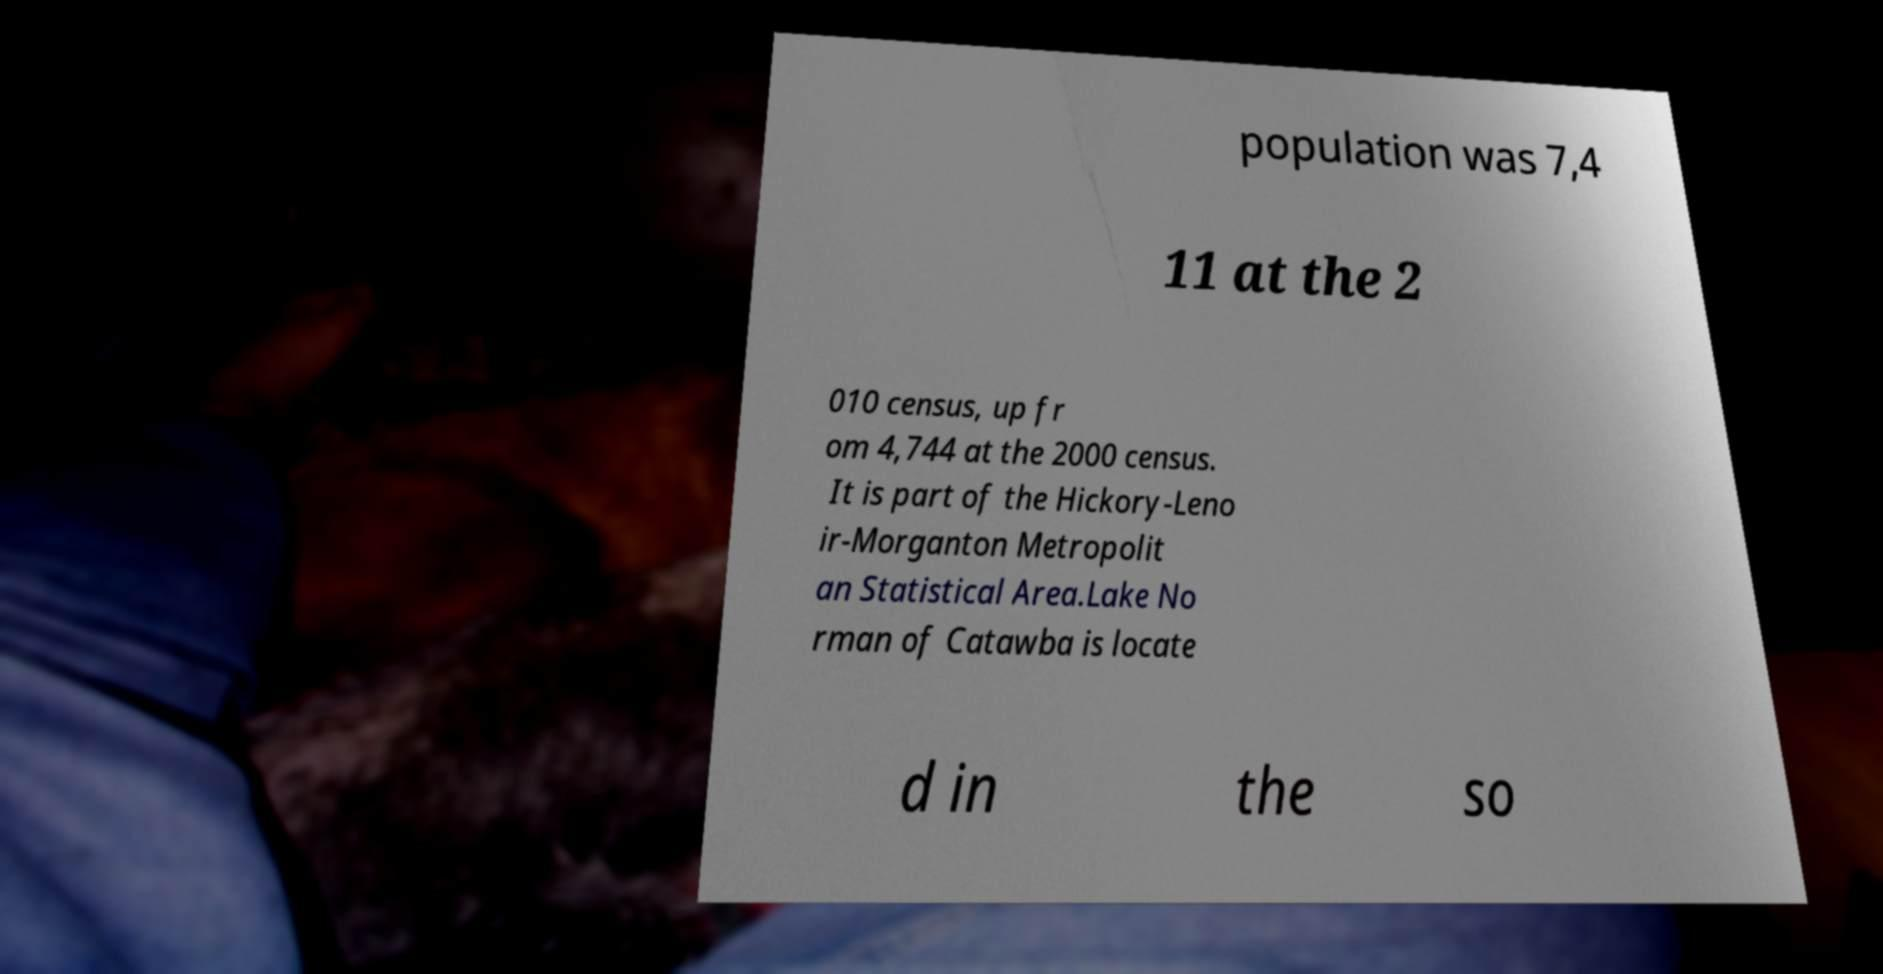What messages or text are displayed in this image? I need them in a readable, typed format. population was 7,4 11 at the 2 010 census, up fr om 4,744 at the 2000 census. It is part of the Hickory-Leno ir-Morganton Metropolit an Statistical Area.Lake No rman of Catawba is locate d in the so 